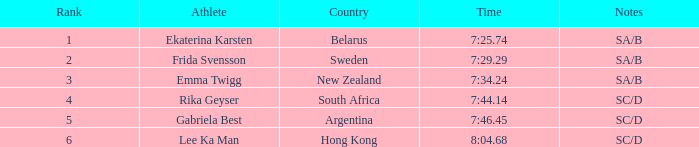What is the complete ranking for the athlete that recorded a race time of 7:3 1.0. 